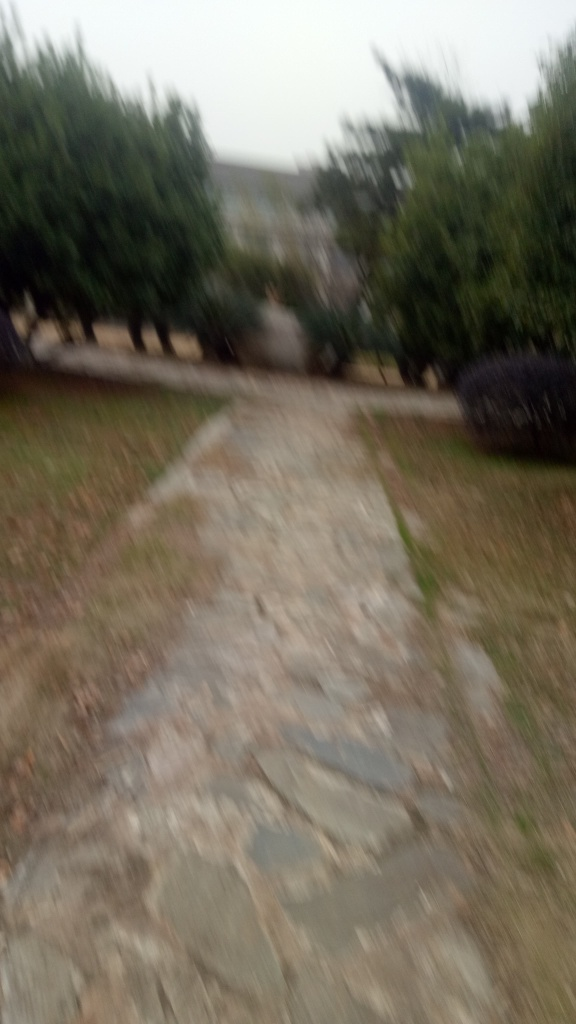Can you tell me about the weather or time of day this photo was taken? Given the diffused natural light and lack of harsh shadows in the image, it appears to be an overcast day or possibly taken during twilight hours when the light is softer. However, the specific details are difficult to discern due to the blurriness of the photo. 